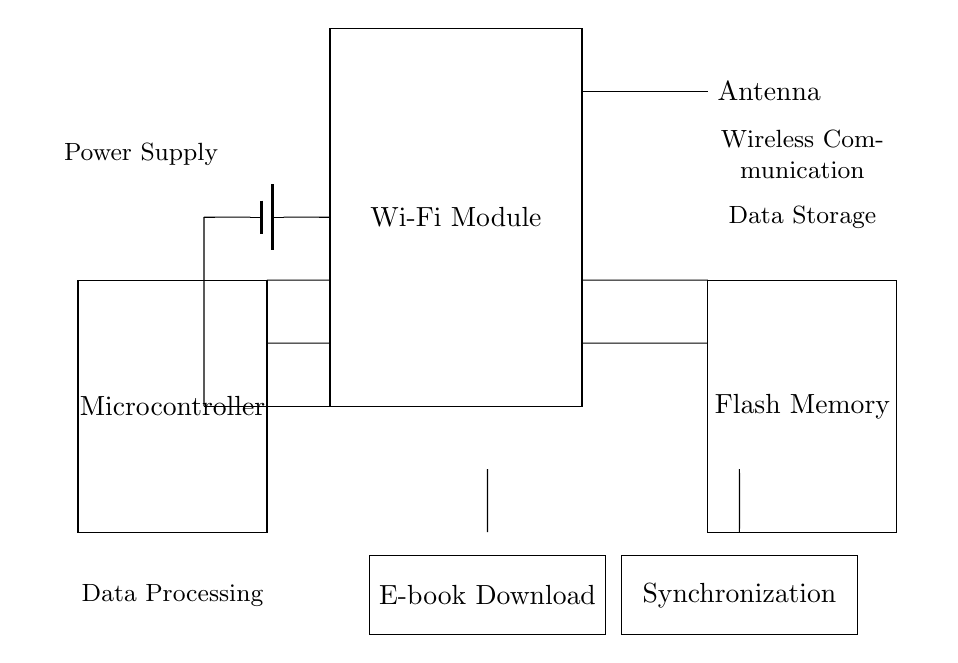What is the primary function of the Wi-Fi module? The primary function of the Wi-Fi module is to facilitate wireless communication, which is indicated by its label in the circuit diagram.
Answer: wireless communication How many components are directly connected to the microcontroller? The microcontroller is connected to two components directly: the Wi-Fi module and the Flash memory, as seen from the direct short connections between them.
Answer: two What type of memory is used for data storage? The memory type used for data storage is Flash Memory, clearly labeled in the circuit diagram.
Answer: Flash Memory Which component acts as the power supply in the circuit? The power supply is represented by a battery symbol connected to the Wi-Fi module and the microcontroller, demonstrating its role as the energy source.
Answer: battery What are the two main functions depicted below the Wi-Fi module? The two main functions depicted are E-book Download and Synchronization, shown as labeled rectangles directly below the Wi-Fi module, indicating their purpose in the circuit.
Answer: E-book Download and Synchronization What is the relationship between the Wi-Fi module and the antenna in this circuit? The relationship is that the Wi-Fi module connects to the antenna; the antenna supports the wireless communication function of the Wi-Fi module as depicted in the diagram.
Answer: supports wireless communication What is the purpose of the short connections seen in the circuit? The short connections in the circuit serve to establish direct electrical pathways between various components, ensuring that data and power can flow accordingly.
Answer: direct pathways 